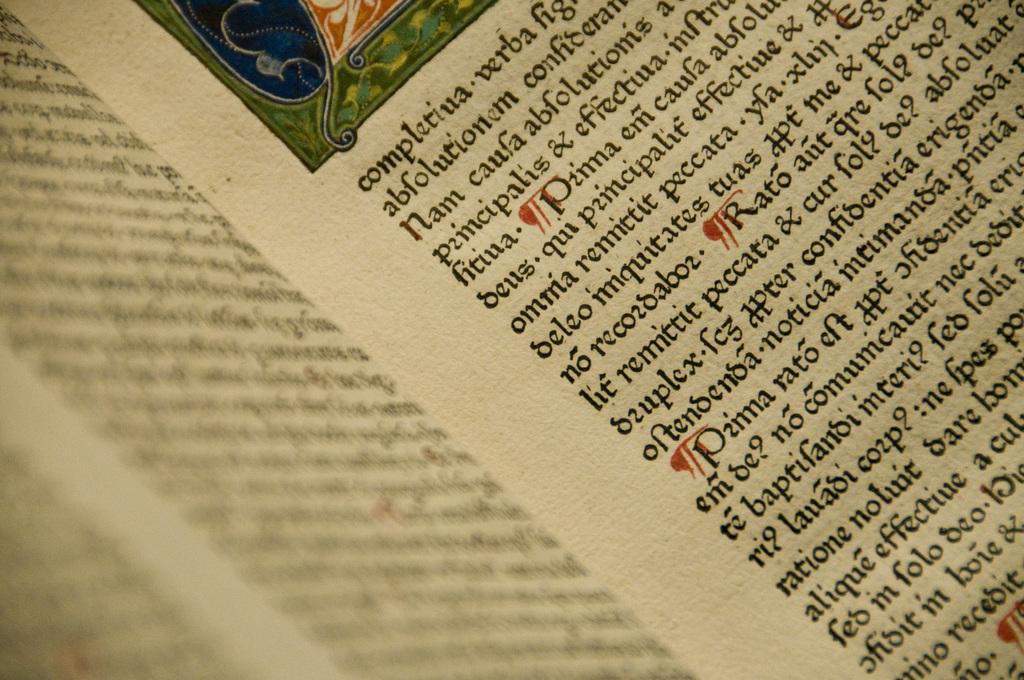What is the main subject of the image? The main subject of the image is a page of a book. Can you describe the content of the page? Unfortunately, the content of the page cannot be determined from the image alone. Is there any other object or element visible in the image? Based on the provided facts, there is no other object or element mentioned. What type of flame can be seen on the page of the book in the image? There is no flame present on the page of the book in the image. Is there a squirrel visible on the page of the book in the image? There is no squirrel present on the page of the book in the image. 